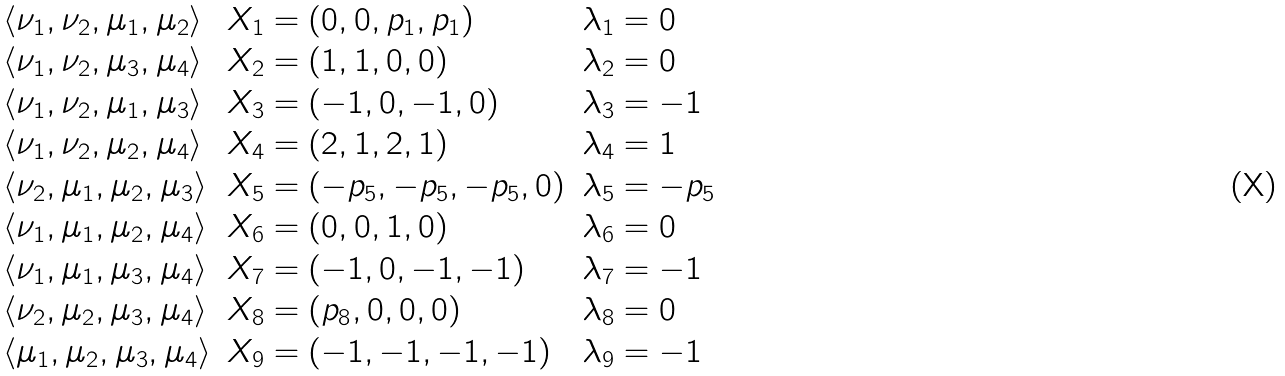<formula> <loc_0><loc_0><loc_500><loc_500>\begin{array} { l l l } \langle \nu _ { 1 } , \nu _ { 2 } , \mu _ { 1 } , \mu _ { 2 } \rangle & X _ { 1 } = ( 0 , 0 , p _ { 1 } , p _ { 1 } ) & \lambda _ { 1 } = 0 \\ \langle \nu _ { 1 } , \nu _ { 2 } , \mu _ { 3 } , \mu _ { 4 } \rangle & X _ { 2 } = ( 1 , 1 , 0 , 0 ) & \lambda _ { 2 } = 0 \\ \langle \nu _ { 1 } , \nu _ { 2 } , \mu _ { 1 } , \mu _ { 3 } \rangle & X _ { 3 } = ( - 1 , 0 , - 1 , 0 ) & \lambda _ { 3 } = - 1 \\ \langle \nu _ { 1 } , \nu _ { 2 } , \mu _ { 2 } , \mu _ { 4 } \rangle & X _ { 4 } = ( 2 , 1 , 2 , 1 ) & \lambda _ { 4 } = 1 \\ \langle \nu _ { 2 } , \mu _ { 1 } , \mu _ { 2 } , \mu _ { 3 } \rangle & X _ { 5 } = ( - p _ { 5 } , - p _ { 5 } , - p _ { 5 } , 0 ) & \lambda _ { 5 } = - p _ { 5 } \\ \langle \nu _ { 1 } , \mu _ { 1 } , \mu _ { 2 } , \mu _ { 4 } \rangle & X _ { 6 } = ( 0 , 0 , 1 , 0 ) & \lambda _ { 6 } = 0 \\ \langle \nu _ { 1 } , \mu _ { 1 } , \mu _ { 3 } , \mu _ { 4 } \rangle & X _ { 7 } = ( - 1 , 0 , - 1 , - 1 ) & \lambda _ { 7 } = - 1 \\ \langle \nu _ { 2 } , \mu _ { 2 } , \mu _ { 3 } , \mu _ { 4 } \rangle & X _ { 8 } = ( p _ { 8 } , 0 , 0 , 0 ) & \lambda _ { 8 } = 0 \\ \langle \mu _ { 1 } , \mu _ { 2 } , \mu _ { 3 } , \mu _ { 4 } \rangle & X _ { 9 } = ( - 1 , - 1 , - 1 , - 1 ) & \lambda _ { 9 } = - 1 \end{array}</formula> 